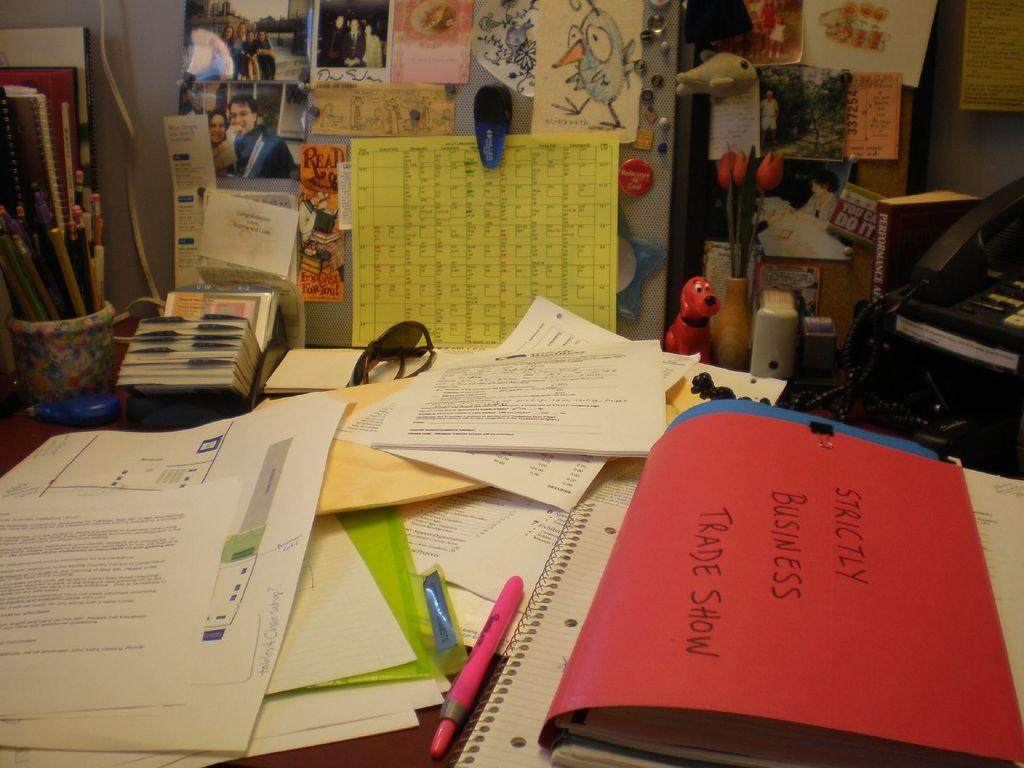<image>
Describe the image concisely. Strictly business trade show sign on a table. 